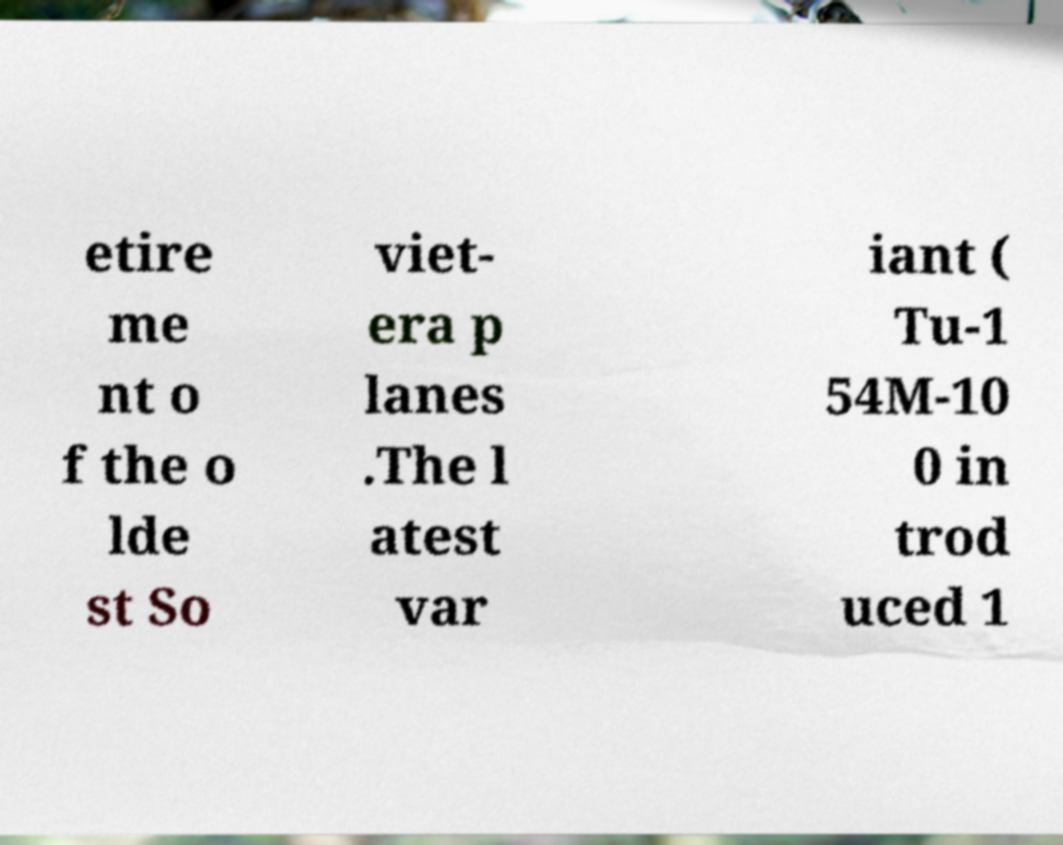Can you read and provide the text displayed in the image?This photo seems to have some interesting text. Can you extract and type it out for me? etire me nt o f the o lde st So viet- era p lanes .The l atest var iant ( Tu-1 54M-10 0 in trod uced 1 